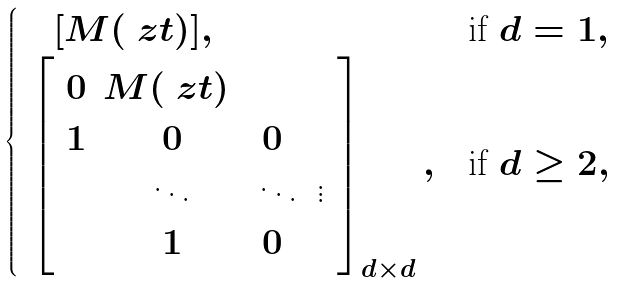<formula> <loc_0><loc_0><loc_500><loc_500>\begin{cases} \quad [ M ( \ z t ) ] , & \text {if $d=1$} , \\ \ \begin{bmatrix} \ 0 & M ( \ z t ) \ \\ \ 1 & 0 & 0 \ \\ & \ddots & \ddots & \vdots \ \\ & 1 & 0 \ \end{bmatrix} _ { d \times d } , & \text {if $d\geq 2$} , \end{cases}</formula> 